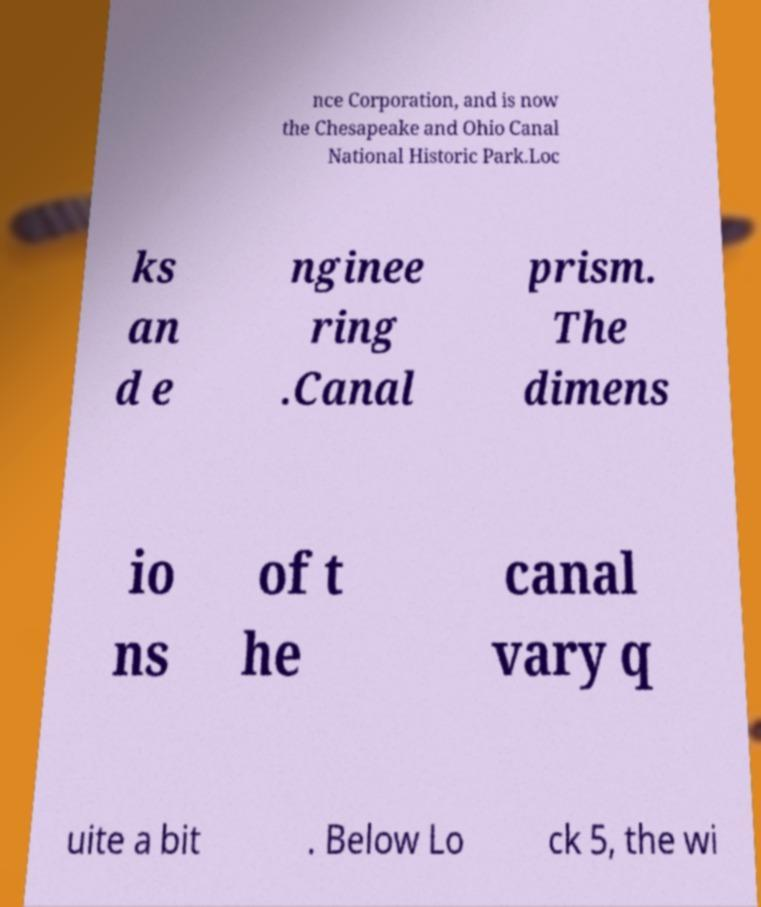Could you extract and type out the text from this image? nce Corporation, and is now the Chesapeake and Ohio Canal National Historic Park.Loc ks an d e nginee ring .Canal prism. The dimens io ns of t he canal vary q uite a bit . Below Lo ck 5, the wi 